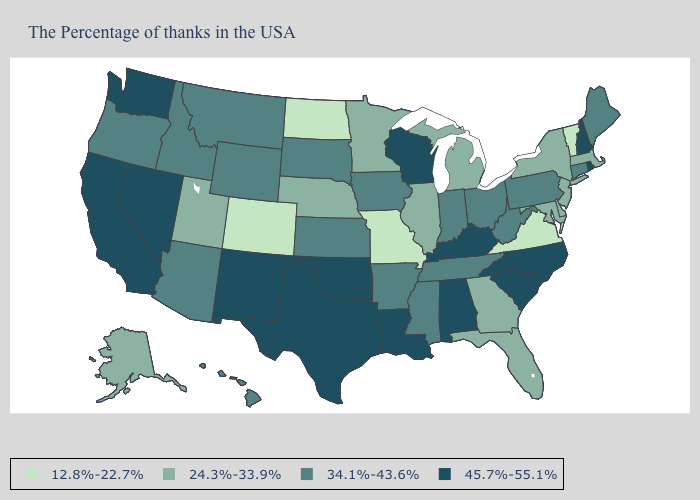Which states have the lowest value in the West?
Keep it brief. Colorado. What is the highest value in states that border Ohio?
Write a very short answer. 45.7%-55.1%. What is the value of New Mexico?
Give a very brief answer. 45.7%-55.1%. Does Wyoming have the same value as West Virginia?
Give a very brief answer. Yes. Does Pennsylvania have the highest value in the USA?
Give a very brief answer. No. Among the states that border New Jersey , which have the lowest value?
Keep it brief. New York, Delaware. What is the highest value in the USA?
Quick response, please. 45.7%-55.1%. Name the states that have a value in the range 24.3%-33.9%?
Answer briefly. Massachusetts, New York, New Jersey, Delaware, Maryland, Florida, Georgia, Michigan, Illinois, Minnesota, Nebraska, Utah, Alaska. Is the legend a continuous bar?
Be succinct. No. What is the value of Indiana?
Quick response, please. 34.1%-43.6%. Does Indiana have the same value as Maine?
Answer briefly. Yes. What is the value of Arkansas?
Keep it brief. 34.1%-43.6%. What is the lowest value in the MidWest?
Concise answer only. 12.8%-22.7%. Name the states that have a value in the range 24.3%-33.9%?
Keep it brief. Massachusetts, New York, New Jersey, Delaware, Maryland, Florida, Georgia, Michigan, Illinois, Minnesota, Nebraska, Utah, Alaska. Does Vermont have the lowest value in the USA?
Quick response, please. Yes. 